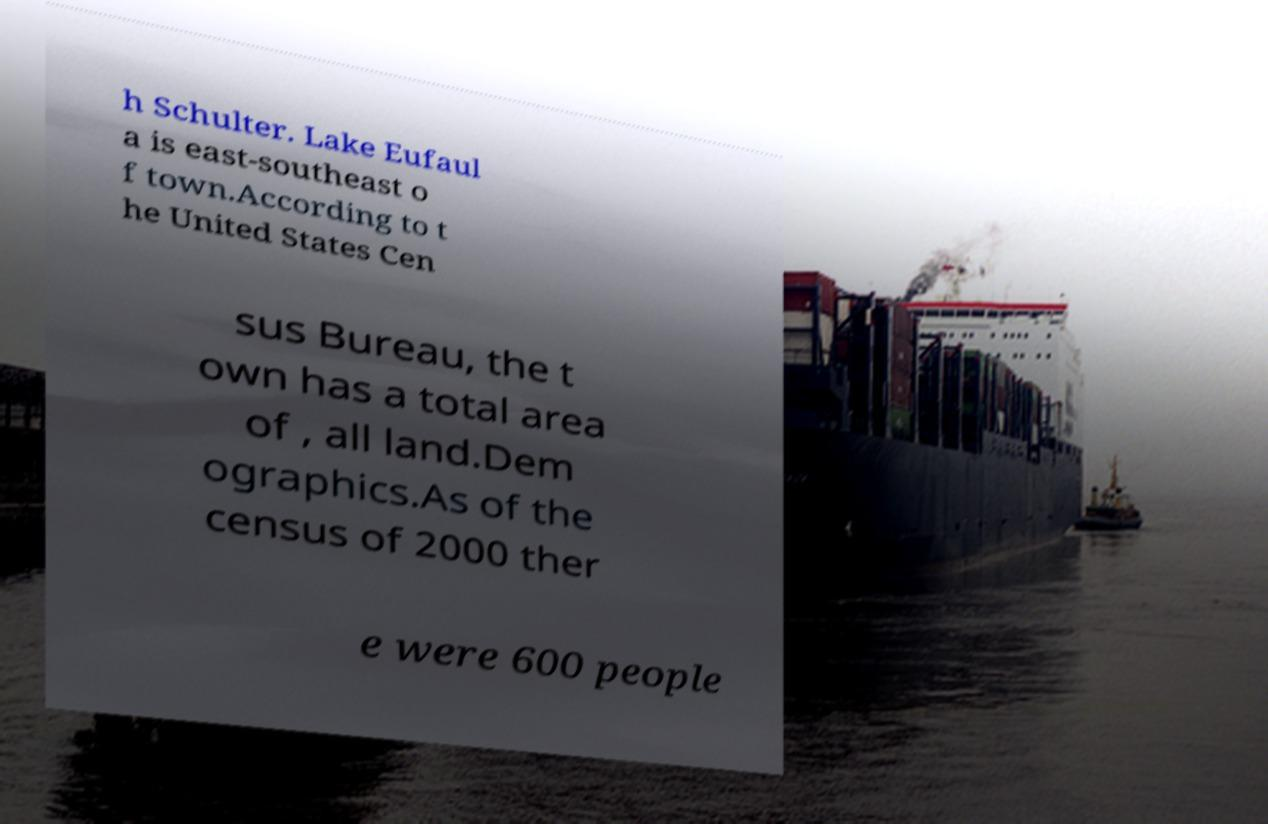Could you assist in decoding the text presented in this image and type it out clearly? h Schulter. Lake Eufaul a is east-southeast o f town.According to t he United States Cen sus Bureau, the t own has a total area of , all land.Dem ographics.As of the census of 2000 ther e were 600 people 